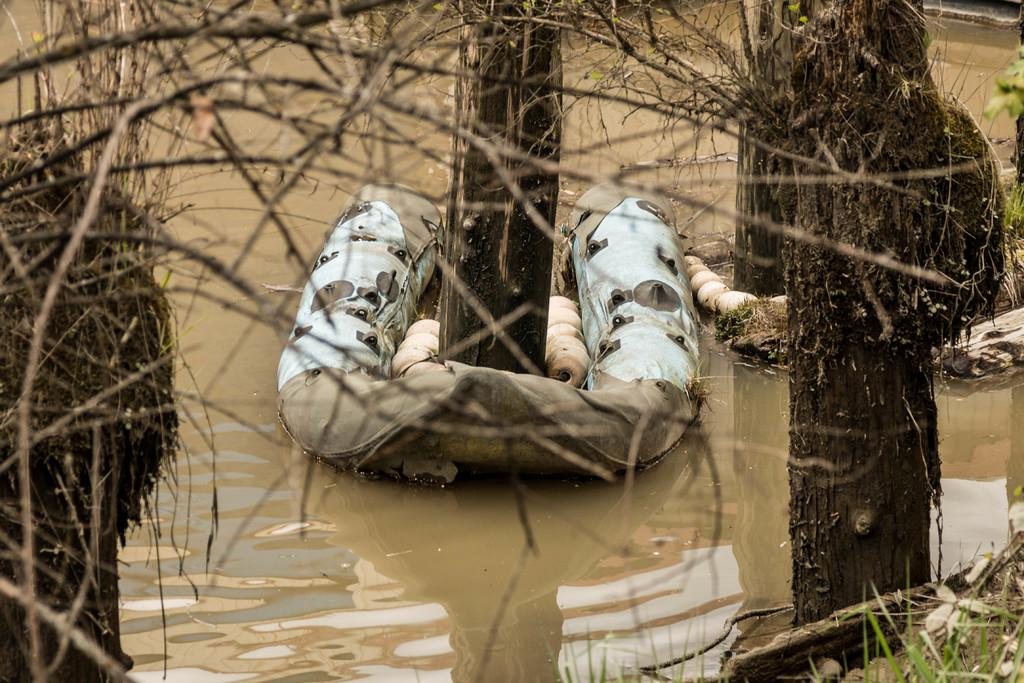What type of vegetation can be seen on both sides of the image? There are trees on the right side and the left side of the image. What is visible in the area surrounding the trees? There is water visible around the area of the image. What flavor of wing can be seen in the image? There are no wings or flavors present in the image; it features trees and water. 